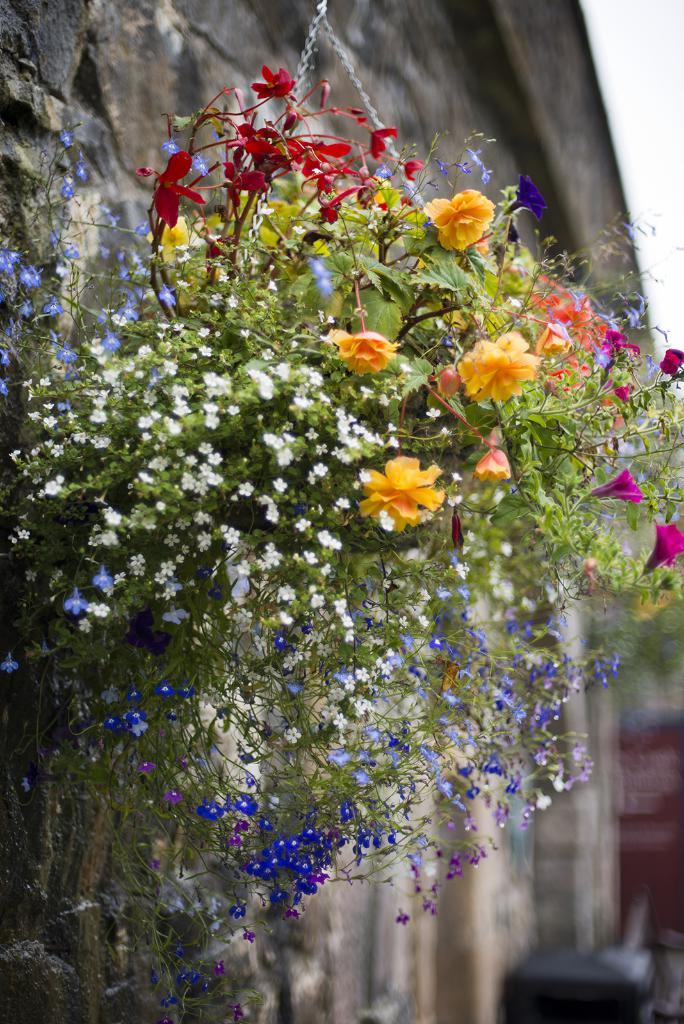What type of plant can be seen in the image? There is a potted plant with flowers in the image. What is the main feature of the background in the image? The background of the image is blurry. What is the primary architectural element in the image? There is a wall in the image. How does the plant sort the flowers in the image? Plants do not have the ability to sort flowers; the flowers are naturally arranged in the potted plant. 